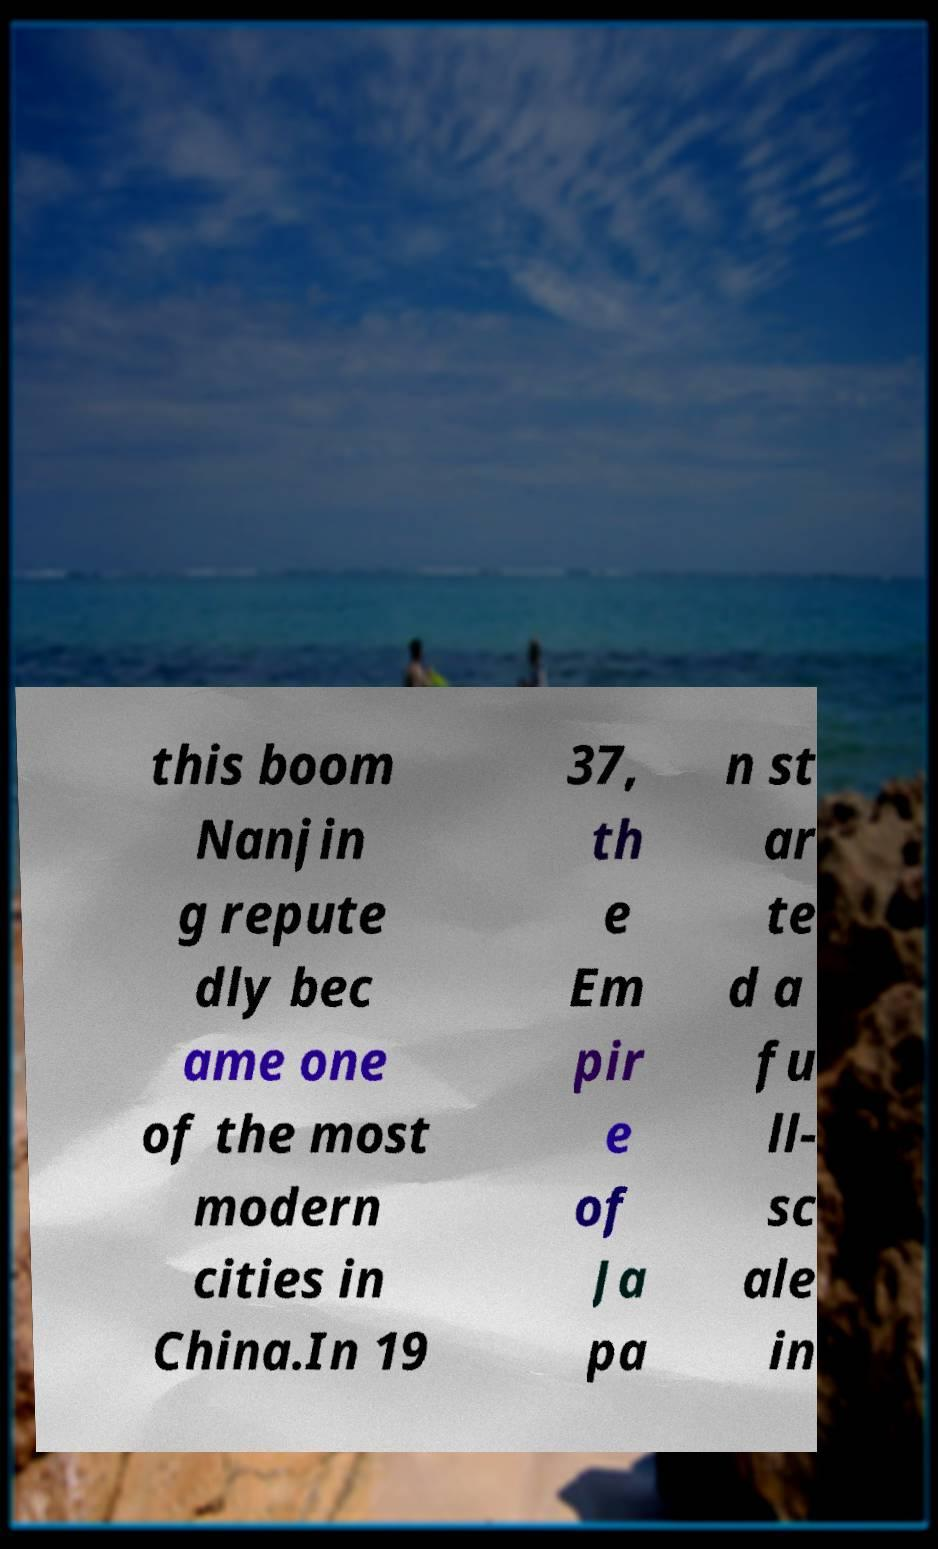What messages or text are displayed in this image? I need them in a readable, typed format. this boom Nanjin g repute dly bec ame one of the most modern cities in China.In 19 37, th e Em pir e of Ja pa n st ar te d a fu ll- sc ale in 